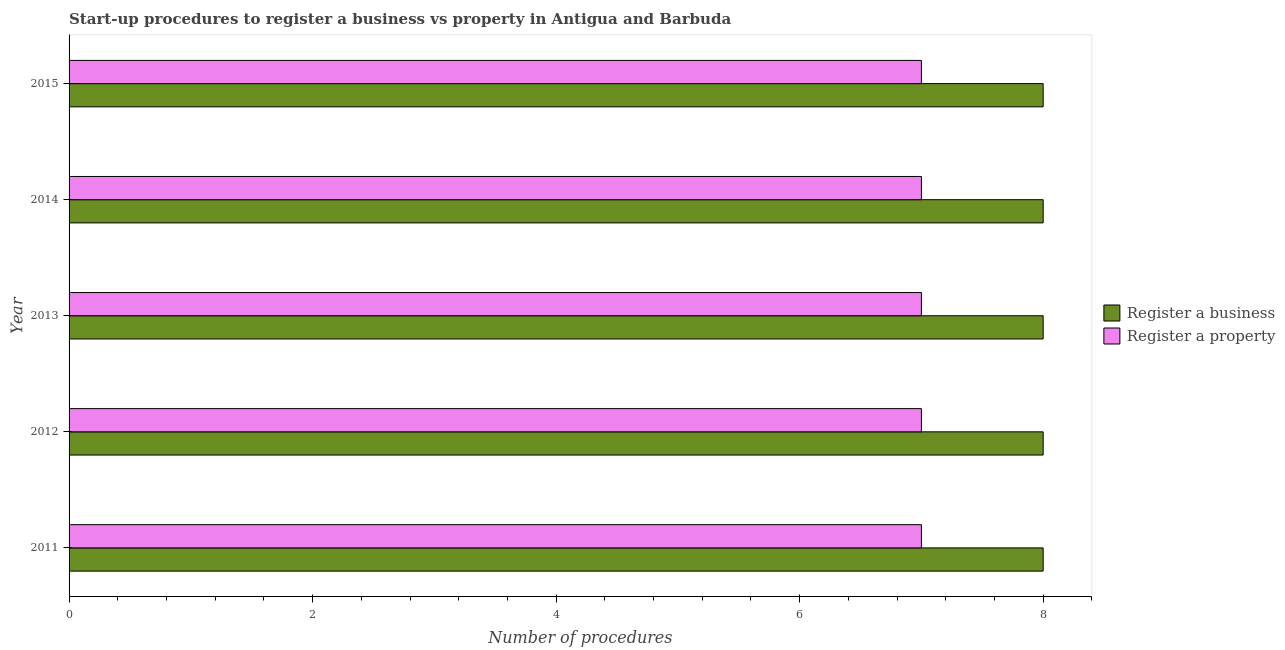Are the number of bars per tick equal to the number of legend labels?
Provide a succinct answer. Yes. Are the number of bars on each tick of the Y-axis equal?
Ensure brevity in your answer.  Yes. What is the number of procedures to register a business in 2013?
Offer a very short reply. 8. Across all years, what is the maximum number of procedures to register a property?
Offer a very short reply. 7. Across all years, what is the minimum number of procedures to register a property?
Ensure brevity in your answer.  7. In which year was the number of procedures to register a business minimum?
Offer a terse response. 2011. What is the total number of procedures to register a business in the graph?
Provide a short and direct response. 40. What is the difference between the number of procedures to register a property in 2011 and that in 2012?
Give a very brief answer. 0. What is the difference between the number of procedures to register a property in 2013 and the number of procedures to register a business in 2015?
Offer a very short reply. -1. In the year 2015, what is the difference between the number of procedures to register a property and number of procedures to register a business?
Your response must be concise. -1. In how many years, is the number of procedures to register a property greater than 1.2000000000000002 ?
Your response must be concise. 5. Is the number of procedures to register a property in 2012 less than that in 2014?
Your response must be concise. No. Is the difference between the number of procedures to register a business in 2013 and 2015 greater than the difference between the number of procedures to register a property in 2013 and 2015?
Ensure brevity in your answer.  No. In how many years, is the number of procedures to register a business greater than the average number of procedures to register a business taken over all years?
Keep it short and to the point. 0. What does the 1st bar from the top in 2012 represents?
Make the answer very short. Register a property. What does the 1st bar from the bottom in 2015 represents?
Provide a succinct answer. Register a business. Are all the bars in the graph horizontal?
Your answer should be very brief. Yes. What is the difference between two consecutive major ticks on the X-axis?
Make the answer very short. 2. Does the graph contain any zero values?
Give a very brief answer. No. Does the graph contain grids?
Make the answer very short. No. What is the title of the graph?
Ensure brevity in your answer.  Start-up procedures to register a business vs property in Antigua and Barbuda. What is the label or title of the X-axis?
Offer a very short reply. Number of procedures. What is the Number of procedures of Register a business in 2011?
Keep it short and to the point. 8. What is the Number of procedures of Register a property in 2011?
Make the answer very short. 7. What is the Number of procedures in Register a property in 2012?
Provide a succinct answer. 7. What is the Number of procedures in Register a business in 2014?
Ensure brevity in your answer.  8. Across all years, what is the maximum Number of procedures of Register a business?
Make the answer very short. 8. Across all years, what is the minimum Number of procedures of Register a property?
Your answer should be compact. 7. What is the difference between the Number of procedures in Register a business in 2011 and that in 2012?
Your answer should be compact. 0. What is the difference between the Number of procedures of Register a property in 2011 and that in 2013?
Your response must be concise. 0. What is the difference between the Number of procedures in Register a business in 2011 and that in 2014?
Offer a terse response. 0. What is the difference between the Number of procedures of Register a property in 2011 and that in 2014?
Make the answer very short. 0. What is the difference between the Number of procedures in Register a business in 2012 and that in 2014?
Keep it short and to the point. 0. What is the difference between the Number of procedures of Register a business in 2012 and that in 2015?
Keep it short and to the point. 0. What is the difference between the Number of procedures of Register a property in 2012 and that in 2015?
Your answer should be very brief. 0. What is the difference between the Number of procedures of Register a business in 2013 and that in 2015?
Keep it short and to the point. 0. What is the difference between the Number of procedures of Register a property in 2014 and that in 2015?
Provide a succinct answer. 0. What is the difference between the Number of procedures in Register a business in 2011 and the Number of procedures in Register a property in 2014?
Provide a succinct answer. 1. What is the difference between the Number of procedures in Register a business in 2011 and the Number of procedures in Register a property in 2015?
Make the answer very short. 1. What is the difference between the Number of procedures in Register a business in 2012 and the Number of procedures in Register a property in 2014?
Your answer should be very brief. 1. What is the difference between the Number of procedures of Register a business in 2012 and the Number of procedures of Register a property in 2015?
Keep it short and to the point. 1. What is the difference between the Number of procedures in Register a business in 2014 and the Number of procedures in Register a property in 2015?
Your answer should be compact. 1. In the year 2015, what is the difference between the Number of procedures in Register a business and Number of procedures in Register a property?
Offer a very short reply. 1. What is the ratio of the Number of procedures in Register a business in 2011 to that in 2012?
Ensure brevity in your answer.  1. What is the ratio of the Number of procedures of Register a business in 2011 to that in 2013?
Offer a very short reply. 1. What is the ratio of the Number of procedures of Register a business in 2011 to that in 2014?
Make the answer very short. 1. What is the ratio of the Number of procedures of Register a property in 2011 to that in 2015?
Offer a very short reply. 1. What is the ratio of the Number of procedures in Register a property in 2012 to that in 2014?
Provide a short and direct response. 1. What is the ratio of the Number of procedures of Register a business in 2013 to that in 2015?
Provide a succinct answer. 1. What is the ratio of the Number of procedures of Register a property in 2013 to that in 2015?
Ensure brevity in your answer.  1. What is the ratio of the Number of procedures of Register a business in 2014 to that in 2015?
Your response must be concise. 1. What is the ratio of the Number of procedures of Register a property in 2014 to that in 2015?
Keep it short and to the point. 1. What is the difference between the highest and the second highest Number of procedures in Register a business?
Ensure brevity in your answer.  0. What is the difference between the highest and the second highest Number of procedures in Register a property?
Offer a terse response. 0. 